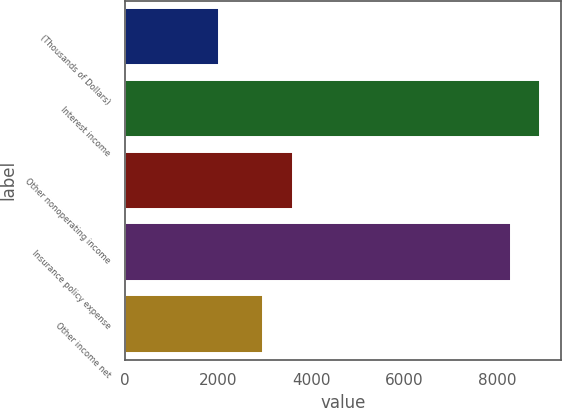<chart> <loc_0><loc_0><loc_500><loc_500><bar_chart><fcel>(Thousands of Dollars)<fcel>Interest income<fcel>Other nonoperating income<fcel>Insurance policy expense<fcel>Other income net<nl><fcel>2013<fcel>8925<fcel>3605<fcel>8292<fcel>2972<nl></chart> 